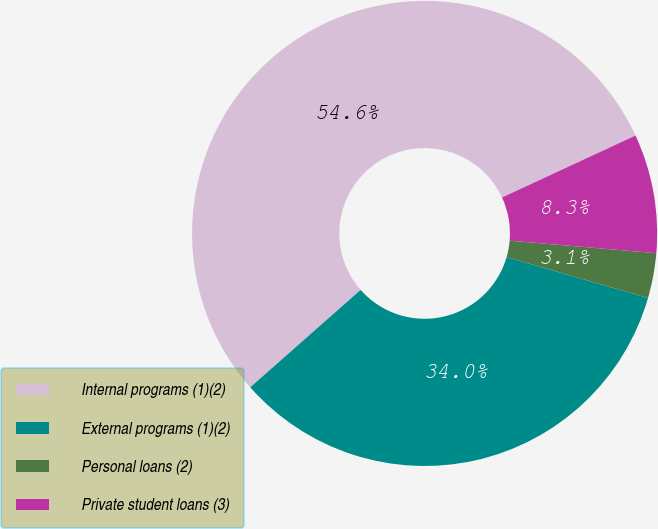Convert chart to OTSL. <chart><loc_0><loc_0><loc_500><loc_500><pie_chart><fcel>Internal programs (1)(2)<fcel>External programs (1)(2)<fcel>Personal loans (2)<fcel>Private student loans (3)<nl><fcel>54.59%<fcel>34.02%<fcel>3.12%<fcel>8.27%<nl></chart> 